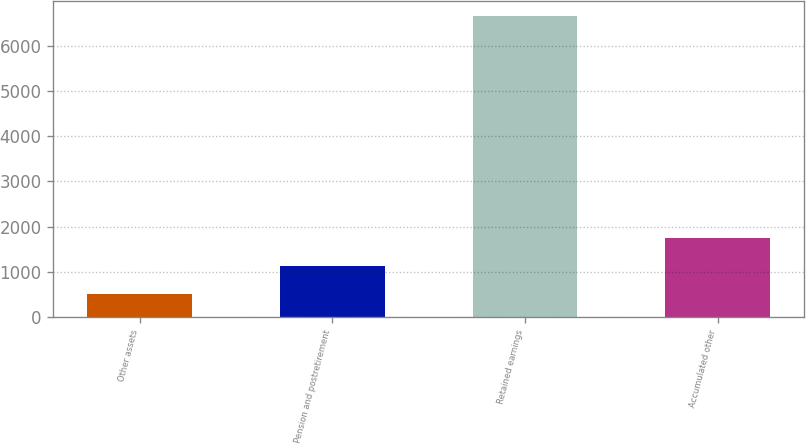<chart> <loc_0><loc_0><loc_500><loc_500><bar_chart><fcel>Other assets<fcel>Pension and postretirement<fcel>Retained earnings<fcel>Accumulated other<nl><fcel>508.4<fcel>1123.43<fcel>6658.7<fcel>1738.46<nl></chart> 